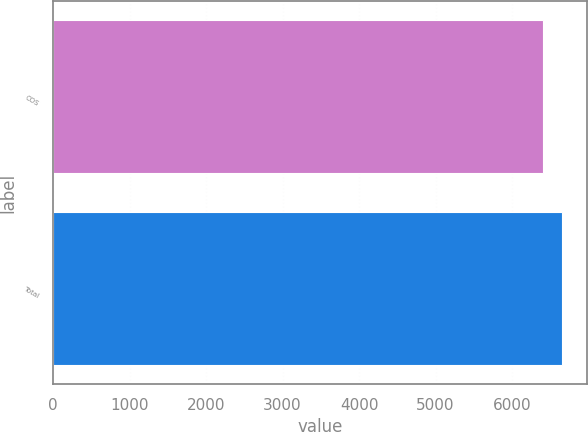Convert chart to OTSL. <chart><loc_0><loc_0><loc_500><loc_500><bar_chart><fcel>COS<fcel>Total<nl><fcel>6400<fcel>6649<nl></chart> 